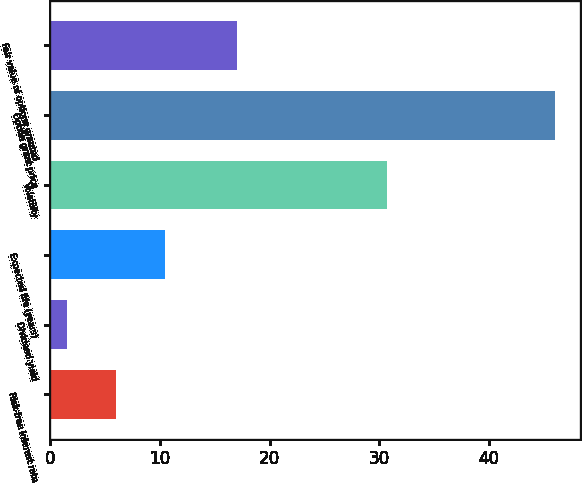<chart> <loc_0><loc_0><loc_500><loc_500><bar_chart><fcel>Risk-free interest rate<fcel>Dividend yield<fcel>Expected life (years)<fcel>Volatility<fcel>Option grant price<fcel>Fair value of options granted<nl><fcel>5.97<fcel>1.52<fcel>10.42<fcel>30.73<fcel>46<fcel>17.01<nl></chart> 